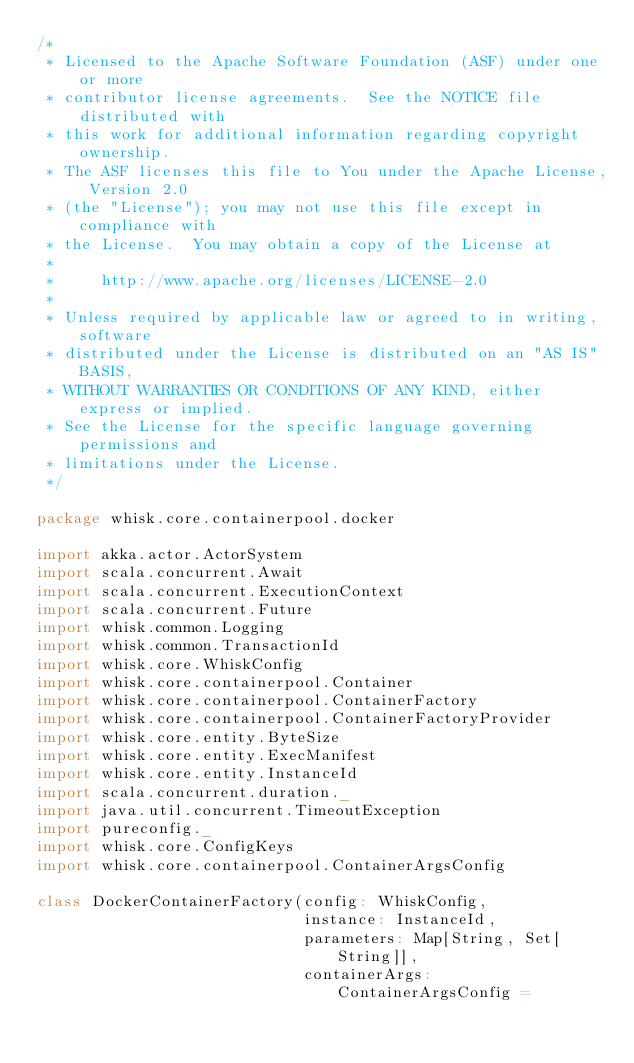<code> <loc_0><loc_0><loc_500><loc_500><_Scala_>/*
 * Licensed to the Apache Software Foundation (ASF) under one or more
 * contributor license agreements.  See the NOTICE file distributed with
 * this work for additional information regarding copyright ownership.
 * The ASF licenses this file to You under the Apache License, Version 2.0
 * (the "License"); you may not use this file except in compliance with
 * the License.  You may obtain a copy of the License at
 *
 *     http://www.apache.org/licenses/LICENSE-2.0
 *
 * Unless required by applicable law or agreed to in writing, software
 * distributed under the License is distributed on an "AS IS" BASIS,
 * WITHOUT WARRANTIES OR CONDITIONS OF ANY KIND, either express or implied.
 * See the License for the specific language governing permissions and
 * limitations under the License.
 */

package whisk.core.containerpool.docker

import akka.actor.ActorSystem
import scala.concurrent.Await
import scala.concurrent.ExecutionContext
import scala.concurrent.Future
import whisk.common.Logging
import whisk.common.TransactionId
import whisk.core.WhiskConfig
import whisk.core.containerpool.Container
import whisk.core.containerpool.ContainerFactory
import whisk.core.containerpool.ContainerFactoryProvider
import whisk.core.entity.ByteSize
import whisk.core.entity.ExecManifest
import whisk.core.entity.InstanceId
import scala.concurrent.duration._
import java.util.concurrent.TimeoutException
import pureconfig._
import whisk.core.ConfigKeys
import whisk.core.containerpool.ContainerArgsConfig

class DockerContainerFactory(config: WhiskConfig,
                             instance: InstanceId,
                             parameters: Map[String, Set[String]],
                             containerArgs: ContainerArgsConfig =</code> 